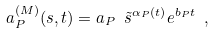<formula> <loc_0><loc_0><loc_500><loc_500>a _ { P } ^ { ( M ) } ( s , t ) = a _ { P } \ \tilde { s } ^ { \alpha _ { P } ( t ) } e ^ { b _ { P } t } \ ,</formula> 